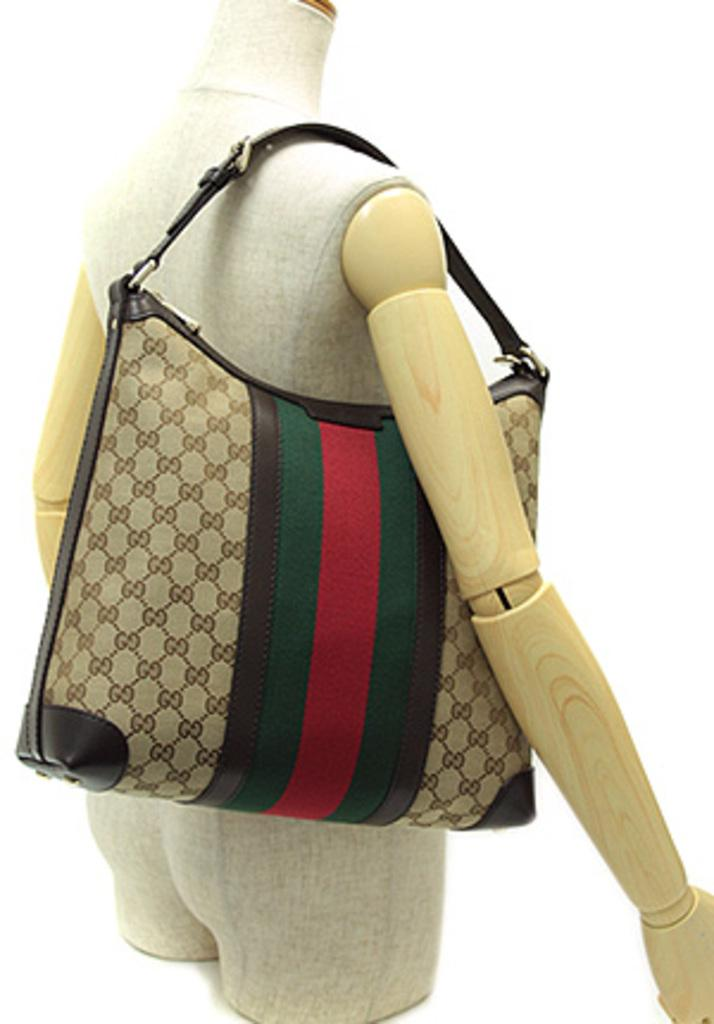What is the main subject in the image? There is a mannequin in the image. What is the mannequin wearing? The mannequin is wearing a handbag. What type of hill can be seen in the background of the image? There is no hill visible in the image; it only features a mannequin wearing a handbag. 